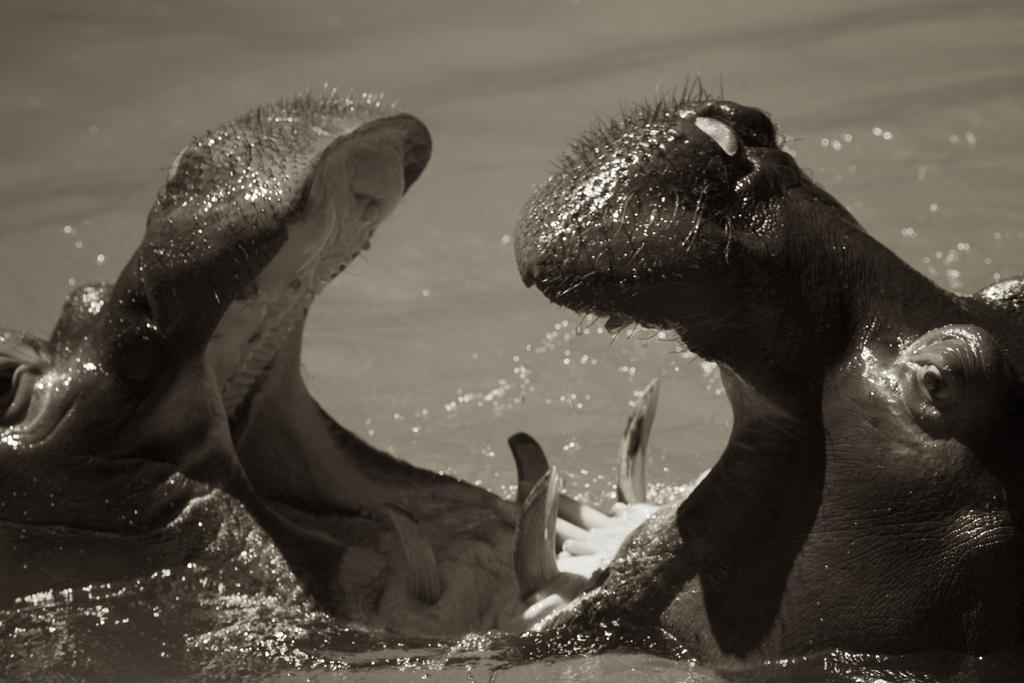What is the color scheme of the image? The image is black and white. What animal can be seen in the water in the image? There is a hippopotamus in the water in the image. What type of lettuce can be seen floating in the water in the image? There is no lettuce present in the image; it features a hippopotamus in the water. What level of water is the hippopotamus submerged in the image? The image does not provide information about the level of water the hippopotamus is submerged in. 